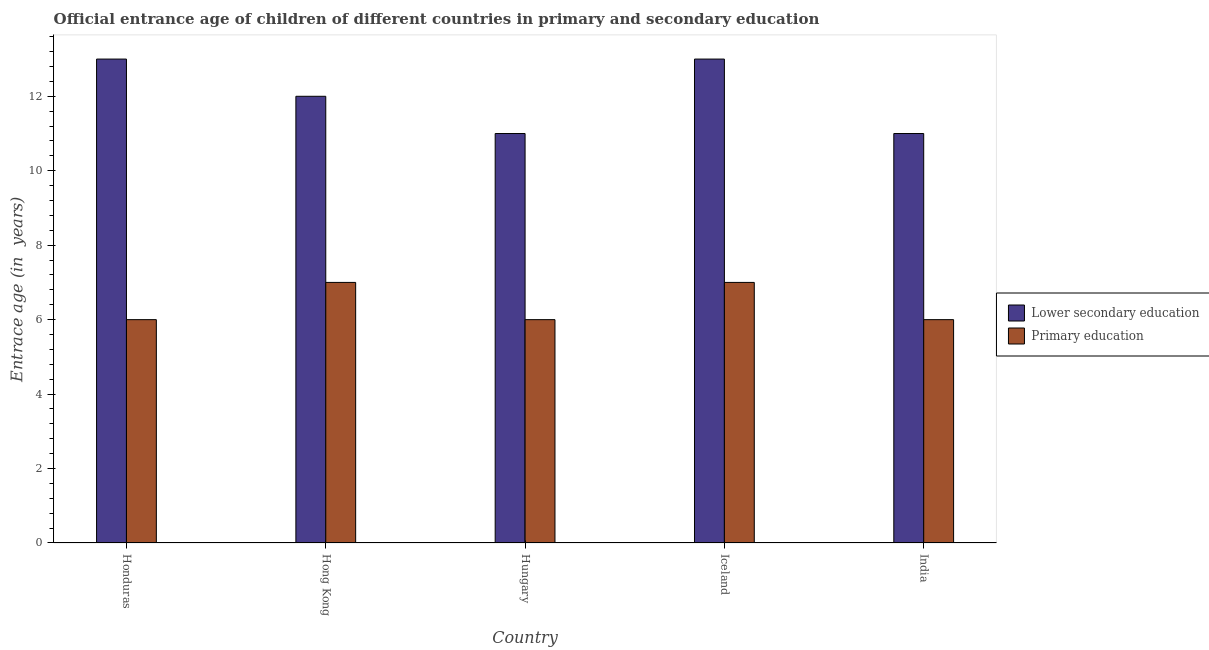How many different coloured bars are there?
Your response must be concise. 2. How many groups of bars are there?
Keep it short and to the point. 5. Are the number of bars on each tick of the X-axis equal?
Your response must be concise. Yes. What is the label of the 1st group of bars from the left?
Offer a very short reply. Honduras. In how many cases, is the number of bars for a given country not equal to the number of legend labels?
Your response must be concise. 0. What is the entrance age of children in lower secondary education in India?
Give a very brief answer. 11. Across all countries, what is the maximum entrance age of children in lower secondary education?
Make the answer very short. 13. Across all countries, what is the minimum entrance age of children in lower secondary education?
Give a very brief answer. 11. In which country was the entrance age of chiildren in primary education maximum?
Keep it short and to the point. Hong Kong. In which country was the entrance age of chiildren in primary education minimum?
Offer a very short reply. Honduras. What is the total entrance age of chiildren in primary education in the graph?
Give a very brief answer. 32. What is the difference between the entrance age of chiildren in primary education in Hungary and that in Iceland?
Provide a succinct answer. -1. What is the difference between the entrance age of chiildren in primary education in Hungary and the entrance age of children in lower secondary education in India?
Give a very brief answer. -5. What is the average entrance age of chiildren in primary education per country?
Provide a succinct answer. 6.4. What is the difference between the entrance age of children in lower secondary education and entrance age of chiildren in primary education in Hungary?
Ensure brevity in your answer.  5. In how many countries, is the entrance age of children in lower secondary education greater than 9.2 years?
Your answer should be very brief. 5. What is the ratio of the entrance age of chiildren in primary education in Hungary to that in Iceland?
Give a very brief answer. 0.86. Is the entrance age of chiildren in primary education in Hong Kong less than that in Iceland?
Your answer should be compact. No. What is the difference between the highest and the second highest entrance age of children in lower secondary education?
Give a very brief answer. 0. What is the difference between the highest and the lowest entrance age of children in lower secondary education?
Offer a terse response. 2. In how many countries, is the entrance age of chiildren in primary education greater than the average entrance age of chiildren in primary education taken over all countries?
Offer a terse response. 2. What does the 1st bar from the right in India represents?
Your answer should be very brief. Primary education. How many bars are there?
Your answer should be very brief. 10. How many countries are there in the graph?
Your answer should be very brief. 5. What is the difference between two consecutive major ticks on the Y-axis?
Your response must be concise. 2. Does the graph contain grids?
Your answer should be very brief. No. Where does the legend appear in the graph?
Ensure brevity in your answer.  Center right. What is the title of the graph?
Offer a terse response. Official entrance age of children of different countries in primary and secondary education. Does "Secondary Education" appear as one of the legend labels in the graph?
Make the answer very short. No. What is the label or title of the Y-axis?
Your answer should be compact. Entrace age (in  years). What is the Entrace age (in  years) in Primary education in Honduras?
Your response must be concise. 6. What is the Entrace age (in  years) of Lower secondary education in Hong Kong?
Ensure brevity in your answer.  12. What is the Entrace age (in  years) in Primary education in Hong Kong?
Provide a succinct answer. 7. What is the Entrace age (in  years) of Lower secondary education in Hungary?
Keep it short and to the point. 11. What is the Entrace age (in  years) in Primary education in Hungary?
Your answer should be compact. 6. Across all countries, what is the maximum Entrace age (in  years) in Lower secondary education?
Provide a short and direct response. 13. Across all countries, what is the maximum Entrace age (in  years) of Primary education?
Ensure brevity in your answer.  7. Across all countries, what is the minimum Entrace age (in  years) of Lower secondary education?
Provide a short and direct response. 11. Across all countries, what is the minimum Entrace age (in  years) in Primary education?
Offer a very short reply. 6. What is the total Entrace age (in  years) in Primary education in the graph?
Make the answer very short. 32. What is the difference between the Entrace age (in  years) in Lower secondary education in Honduras and that in Hong Kong?
Keep it short and to the point. 1. What is the difference between the Entrace age (in  years) in Lower secondary education in Honduras and that in Iceland?
Offer a terse response. 0. What is the difference between the Entrace age (in  years) in Primary education in Honduras and that in Iceland?
Offer a terse response. -1. What is the difference between the Entrace age (in  years) of Lower secondary education in Honduras and that in India?
Your response must be concise. 2. What is the difference between the Entrace age (in  years) in Primary education in Honduras and that in India?
Your answer should be compact. 0. What is the difference between the Entrace age (in  years) of Lower secondary education in Hong Kong and that in Hungary?
Give a very brief answer. 1. What is the difference between the Entrace age (in  years) in Primary education in Hong Kong and that in Iceland?
Ensure brevity in your answer.  0. What is the difference between the Entrace age (in  years) of Lower secondary education in Hong Kong and that in India?
Provide a succinct answer. 1. What is the difference between the Entrace age (in  years) of Lower secondary education in Hungary and that in Iceland?
Give a very brief answer. -2. What is the difference between the Entrace age (in  years) of Primary education in Hungary and that in India?
Your answer should be very brief. 0. What is the difference between the Entrace age (in  years) of Lower secondary education in Iceland and that in India?
Make the answer very short. 2. What is the difference between the Entrace age (in  years) of Lower secondary education in Hong Kong and the Entrace age (in  years) of Primary education in Iceland?
Give a very brief answer. 5. What is the difference between the Entrace age (in  years) in Lower secondary education in Hong Kong and the Entrace age (in  years) in Primary education in India?
Ensure brevity in your answer.  6. What is the difference between the Entrace age (in  years) in Lower secondary education in Hungary and the Entrace age (in  years) in Primary education in Iceland?
Offer a terse response. 4. What is the difference between the Entrace age (in  years) in Lower secondary education in Iceland and the Entrace age (in  years) in Primary education in India?
Provide a succinct answer. 7. What is the average Entrace age (in  years) in Lower secondary education per country?
Make the answer very short. 12. What is the average Entrace age (in  years) of Primary education per country?
Offer a very short reply. 6.4. What is the difference between the Entrace age (in  years) of Lower secondary education and Entrace age (in  years) of Primary education in Hungary?
Your response must be concise. 5. What is the difference between the Entrace age (in  years) in Lower secondary education and Entrace age (in  years) in Primary education in India?
Keep it short and to the point. 5. What is the ratio of the Entrace age (in  years) in Primary education in Honduras to that in Hong Kong?
Offer a very short reply. 0.86. What is the ratio of the Entrace age (in  years) of Lower secondary education in Honduras to that in Hungary?
Your answer should be compact. 1.18. What is the ratio of the Entrace age (in  years) in Lower secondary education in Honduras to that in India?
Your response must be concise. 1.18. What is the ratio of the Entrace age (in  years) of Primary education in Honduras to that in India?
Provide a succinct answer. 1. What is the ratio of the Entrace age (in  years) of Lower secondary education in Hong Kong to that in Hungary?
Provide a short and direct response. 1.09. What is the ratio of the Entrace age (in  years) of Lower secondary education in Hong Kong to that in India?
Offer a very short reply. 1.09. What is the ratio of the Entrace age (in  years) of Lower secondary education in Hungary to that in Iceland?
Your response must be concise. 0.85. What is the ratio of the Entrace age (in  years) of Lower secondary education in Hungary to that in India?
Give a very brief answer. 1. What is the ratio of the Entrace age (in  years) of Lower secondary education in Iceland to that in India?
Your answer should be very brief. 1.18. What is the ratio of the Entrace age (in  years) in Primary education in Iceland to that in India?
Provide a short and direct response. 1.17. What is the difference between the highest and the second highest Entrace age (in  years) in Primary education?
Ensure brevity in your answer.  0. 